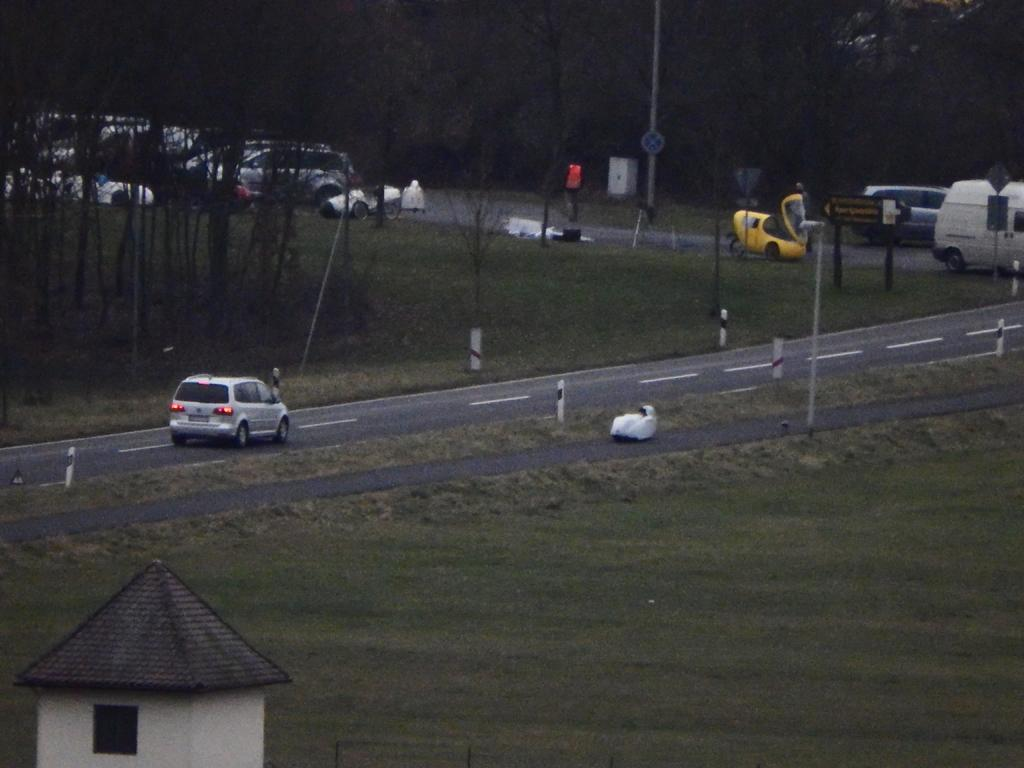What type of landscape is depicted in the image? There is a field in the image. What else can be seen in the image besides the field? There is a road in the image, as well as vehicles on the road. What is visible in the background of the image? There are trees in the background of the image. Is there any sign of human habitation in the image? Yes, there is a small house in the top left corner of the image. What type of cherry is being harvested from the trees in the image? There are no cherries or trees bearing fruit in the image; the trees are in the background and do not have any visible fruit. 